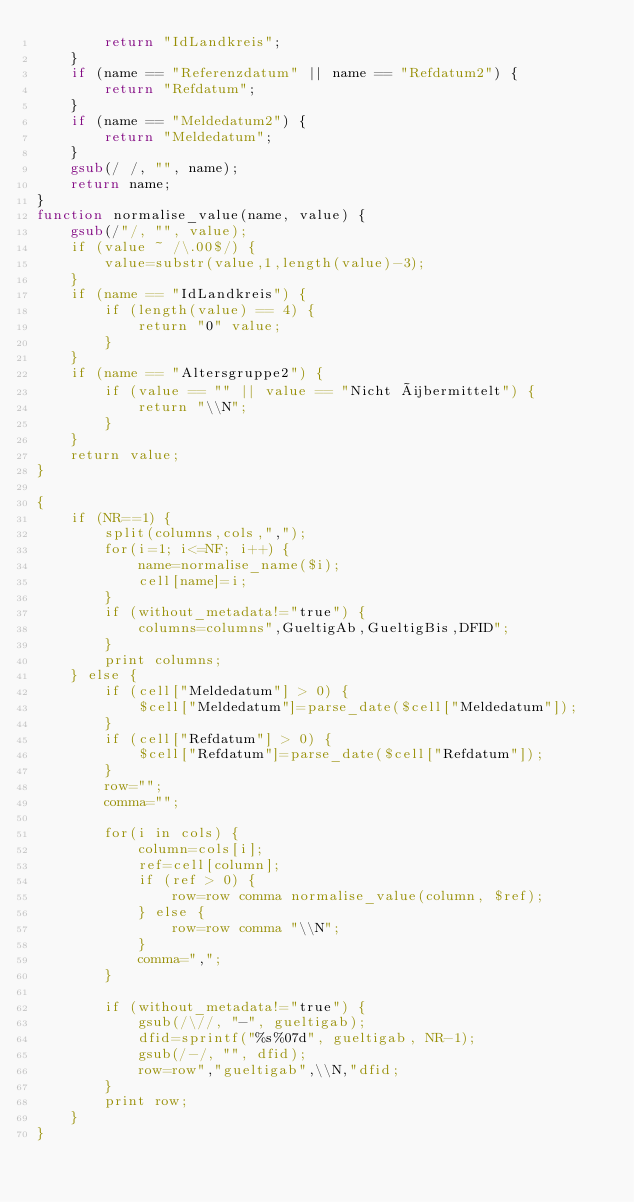Convert code to text. <code><loc_0><loc_0><loc_500><loc_500><_Awk_>        return "IdLandkreis";
    }
    if (name == "Referenzdatum" || name == "Refdatum2") {
        return "Refdatum";
    }
    if (name == "Meldedatum2") {
        return "Meldedatum";
    }
    gsub(/ /, "", name);
    return name;
}
function normalise_value(name, value) {
    gsub(/"/, "", value);
    if (value ~ /\.00$/) {
        value=substr(value,1,length(value)-3);
    }
    if (name == "IdLandkreis") {
        if (length(value) == 4) {
            return "0" value;
        }
    }
    if (name == "Altersgruppe2") {
        if (value == "" || value == "Nicht übermittelt") {
            return "\\N";
        }
    }
    return value;
}

{
    if (NR==1) {
        split(columns,cols,",");
        for(i=1; i<=NF; i++) {
            name=normalise_name($i);
            cell[name]=i;
        }
        if (without_metadata!="true") {
            columns=columns",GueltigAb,GueltigBis,DFID";
        }
        print columns;
    } else {
        if (cell["Meldedatum"] > 0) {
            $cell["Meldedatum"]=parse_date($cell["Meldedatum"]);
        }
        if (cell["Refdatum"] > 0) {
            $cell["Refdatum"]=parse_date($cell["Refdatum"]);
        }
        row="";
        comma="";

        for(i in cols) {
            column=cols[i];
            ref=cell[column];
            if (ref > 0) {
                row=row comma normalise_value(column, $ref);
            } else {
                row=row comma "\\N";
            }
            comma=",";
        }

        if (without_metadata!="true") {
            gsub(/\//, "-", gueltigab);
            dfid=sprintf("%s%07d", gueltigab, NR-1);
            gsub(/-/, "", dfid);
            row=row","gueltigab",\\N,"dfid;
        }
        print row;
    }
}
</code> 